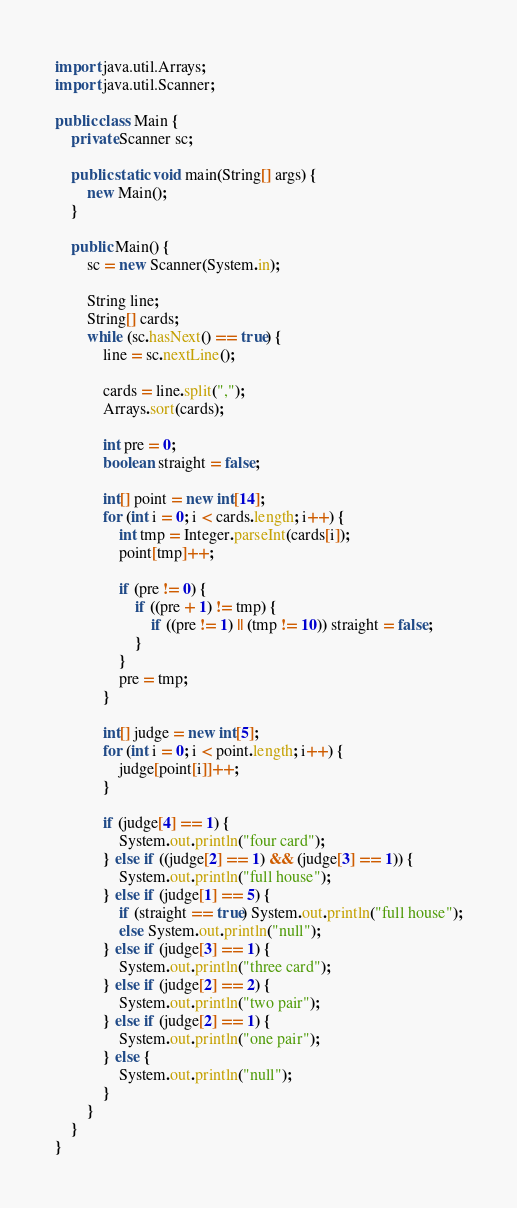Convert code to text. <code><loc_0><loc_0><loc_500><loc_500><_Java_>import java.util.Arrays;
import java.util.Scanner;

public class Main {
	private Scanner sc;
	
	public static void main(String[] args) {
		new Main();
	}
	
	public Main() {
		sc = new Scanner(System.in);

		String line;
		String[] cards;
		while (sc.hasNext() == true) {
			line = sc.nextLine();
			
			cards = line.split(",");
			Arrays.sort(cards);
			
			int pre = 0;
			boolean straight = false;
			
			int[] point = new int[14];
			for (int i = 0; i < cards.length; i++) {
				int tmp = Integer.parseInt(cards[i]);
				point[tmp]++;
				
				if (pre != 0) {
					if ((pre + 1) != tmp) {
						if ((pre != 1) || (tmp != 10)) straight = false;
					}
				}
				pre = tmp;
			}
			
			int[] judge = new int[5];
			for (int i = 0; i < point.length; i++) {
				judge[point[i]]++;
			}
			
			if (judge[4] == 1) {
				System.out.println("four card");
			} else if ((judge[2] == 1) && (judge[3] == 1)) {
				System.out.println("full house");
			} else if (judge[1] == 5) {
				if (straight == true) System.out.println("full house");
				else System.out.println("null");
			} else if (judge[3] == 1) {
				System.out.println("three card");
			} else if (judge[2] == 2) {
				System.out.println("two pair");
			} else if (judge[2] == 1) {
				System.out.println("one pair");
			} else {
				System.out.println("null");
			}
		}
	}
}</code> 